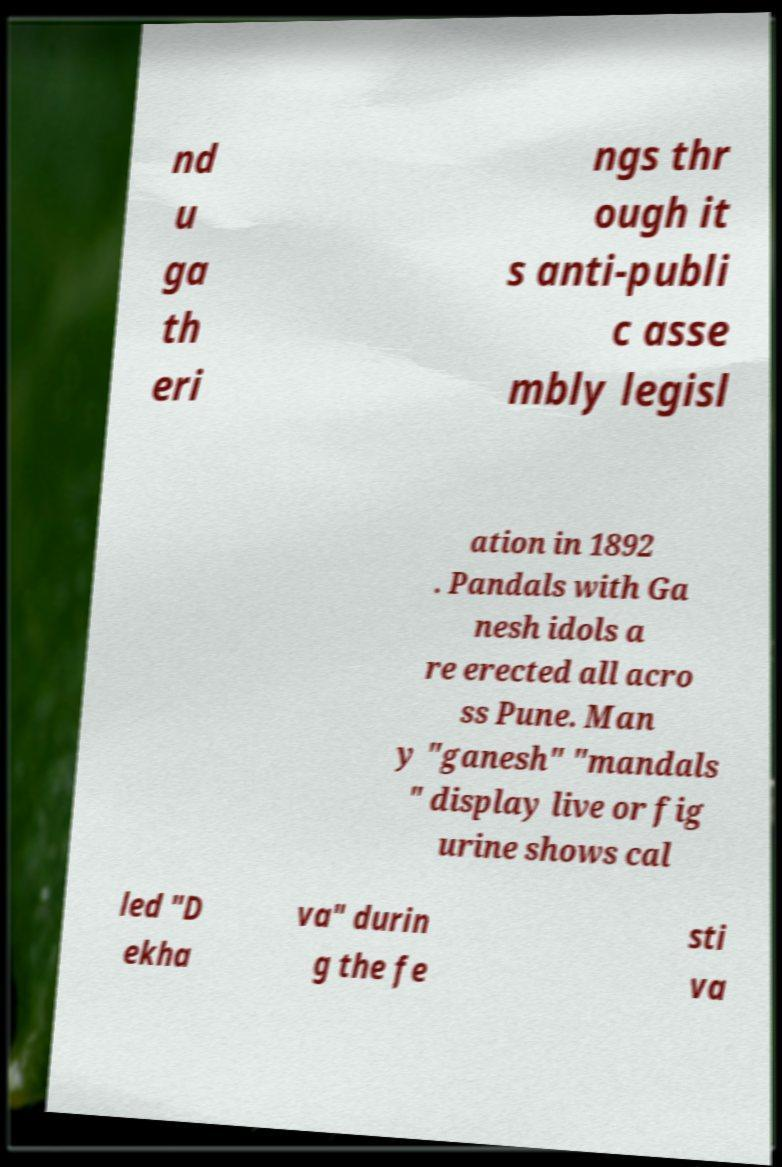Please read and relay the text visible in this image. What does it say? nd u ga th eri ngs thr ough it s anti-publi c asse mbly legisl ation in 1892 . Pandals with Ga nesh idols a re erected all acro ss Pune. Man y "ganesh" "mandals " display live or fig urine shows cal led "D ekha va" durin g the fe sti va 